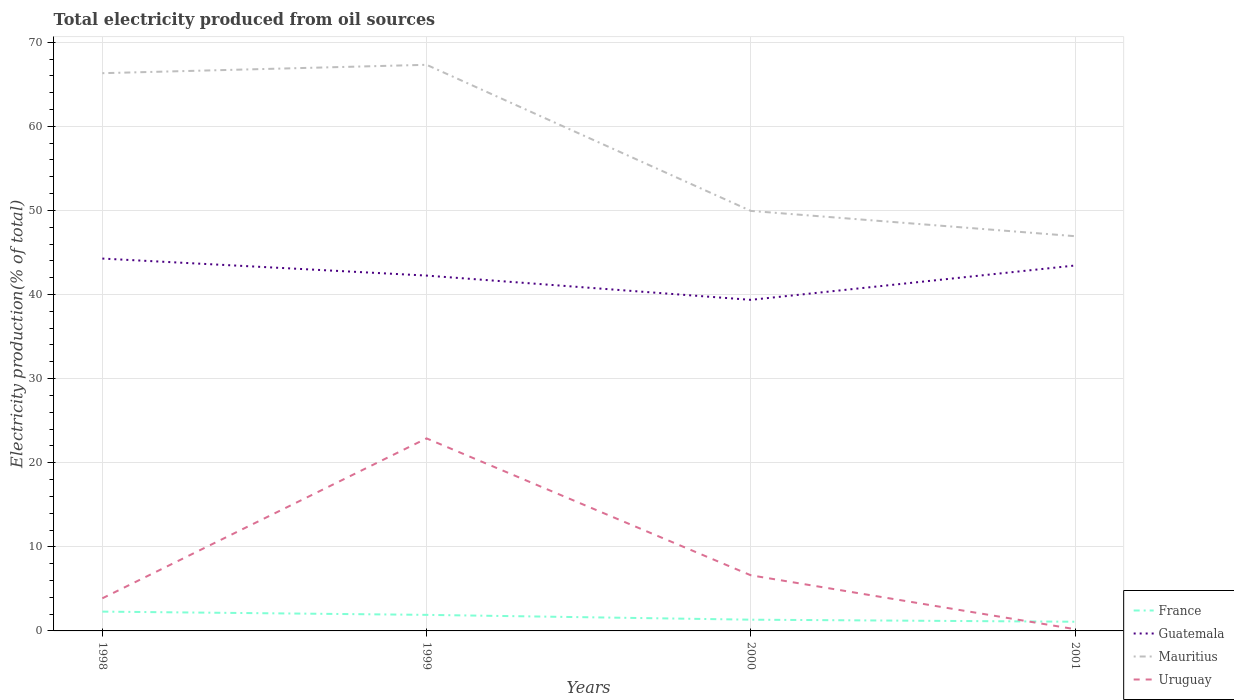Across all years, what is the maximum total electricity produced in Guatemala?
Your answer should be compact. 39.37. In which year was the total electricity produced in Uruguay maximum?
Provide a short and direct response. 2001. What is the total total electricity produced in Mauritius in the graph?
Give a very brief answer. 3. What is the difference between the highest and the second highest total electricity produced in Guatemala?
Your answer should be compact. 4.91. What is the difference between the highest and the lowest total electricity produced in Uruguay?
Provide a succinct answer. 1. Is the total electricity produced in Guatemala strictly greater than the total electricity produced in Mauritius over the years?
Your answer should be very brief. Yes. How many years are there in the graph?
Your answer should be very brief. 4. What is the difference between two consecutive major ticks on the Y-axis?
Ensure brevity in your answer.  10. How are the legend labels stacked?
Offer a very short reply. Vertical. What is the title of the graph?
Keep it short and to the point. Total electricity produced from oil sources. What is the Electricity production(% of total) of France in 1998?
Provide a succinct answer. 2.3. What is the Electricity production(% of total) in Guatemala in 1998?
Your answer should be very brief. 44.28. What is the Electricity production(% of total) in Mauritius in 1998?
Give a very brief answer. 66.32. What is the Electricity production(% of total) of Uruguay in 1998?
Give a very brief answer. 3.88. What is the Electricity production(% of total) of France in 1999?
Ensure brevity in your answer.  1.91. What is the Electricity production(% of total) in Guatemala in 1999?
Provide a short and direct response. 42.25. What is the Electricity production(% of total) in Mauritius in 1999?
Your response must be concise. 67.32. What is the Electricity production(% of total) of Uruguay in 1999?
Ensure brevity in your answer.  22.89. What is the Electricity production(% of total) in France in 2000?
Offer a very short reply. 1.34. What is the Electricity production(% of total) of Guatemala in 2000?
Your answer should be compact. 39.37. What is the Electricity production(% of total) of Mauritius in 2000?
Ensure brevity in your answer.  49.94. What is the Electricity production(% of total) of Uruguay in 2000?
Your response must be concise. 6.62. What is the Electricity production(% of total) of France in 2001?
Your response must be concise. 1.09. What is the Electricity production(% of total) in Guatemala in 2001?
Ensure brevity in your answer.  43.45. What is the Electricity production(% of total) of Mauritius in 2001?
Your answer should be compact. 46.94. What is the Electricity production(% of total) in Uruguay in 2001?
Offer a terse response. 0.21. Across all years, what is the maximum Electricity production(% of total) of France?
Your answer should be very brief. 2.3. Across all years, what is the maximum Electricity production(% of total) of Guatemala?
Provide a succinct answer. 44.28. Across all years, what is the maximum Electricity production(% of total) in Mauritius?
Keep it short and to the point. 67.32. Across all years, what is the maximum Electricity production(% of total) of Uruguay?
Provide a succinct answer. 22.89. Across all years, what is the minimum Electricity production(% of total) in France?
Give a very brief answer. 1.09. Across all years, what is the minimum Electricity production(% of total) in Guatemala?
Keep it short and to the point. 39.37. Across all years, what is the minimum Electricity production(% of total) of Mauritius?
Your answer should be very brief. 46.94. Across all years, what is the minimum Electricity production(% of total) in Uruguay?
Keep it short and to the point. 0.21. What is the total Electricity production(% of total) in France in the graph?
Provide a short and direct response. 6.63. What is the total Electricity production(% of total) in Guatemala in the graph?
Your answer should be compact. 169.35. What is the total Electricity production(% of total) in Mauritius in the graph?
Provide a short and direct response. 230.52. What is the total Electricity production(% of total) of Uruguay in the graph?
Make the answer very short. 33.59. What is the difference between the Electricity production(% of total) in France in 1998 and that in 1999?
Keep it short and to the point. 0.39. What is the difference between the Electricity production(% of total) of Guatemala in 1998 and that in 1999?
Your answer should be very brief. 2.02. What is the difference between the Electricity production(% of total) in Mauritius in 1998 and that in 1999?
Provide a succinct answer. -1. What is the difference between the Electricity production(% of total) of Uruguay in 1998 and that in 1999?
Your answer should be very brief. -19.02. What is the difference between the Electricity production(% of total) in France in 1998 and that in 2000?
Ensure brevity in your answer.  0.96. What is the difference between the Electricity production(% of total) in Guatemala in 1998 and that in 2000?
Give a very brief answer. 4.91. What is the difference between the Electricity production(% of total) of Mauritius in 1998 and that in 2000?
Keep it short and to the point. 16.38. What is the difference between the Electricity production(% of total) in Uruguay in 1998 and that in 2000?
Give a very brief answer. -2.74. What is the difference between the Electricity production(% of total) of France in 1998 and that in 2001?
Make the answer very short. 1.2. What is the difference between the Electricity production(% of total) in Guatemala in 1998 and that in 2001?
Offer a very short reply. 0.83. What is the difference between the Electricity production(% of total) of Mauritius in 1998 and that in 2001?
Make the answer very short. 19.38. What is the difference between the Electricity production(% of total) in Uruguay in 1998 and that in 2001?
Offer a very short reply. 3.67. What is the difference between the Electricity production(% of total) in France in 1999 and that in 2000?
Your answer should be compact. 0.57. What is the difference between the Electricity production(% of total) of Guatemala in 1999 and that in 2000?
Your answer should be very brief. 2.89. What is the difference between the Electricity production(% of total) of Mauritius in 1999 and that in 2000?
Offer a terse response. 17.37. What is the difference between the Electricity production(% of total) of Uruguay in 1999 and that in 2000?
Ensure brevity in your answer.  16.28. What is the difference between the Electricity production(% of total) of France in 1999 and that in 2001?
Your answer should be very brief. 0.82. What is the difference between the Electricity production(% of total) in Guatemala in 1999 and that in 2001?
Ensure brevity in your answer.  -1.2. What is the difference between the Electricity production(% of total) of Mauritius in 1999 and that in 2001?
Keep it short and to the point. 20.38. What is the difference between the Electricity production(% of total) of Uruguay in 1999 and that in 2001?
Your answer should be very brief. 22.69. What is the difference between the Electricity production(% of total) of France in 2000 and that in 2001?
Keep it short and to the point. 0.24. What is the difference between the Electricity production(% of total) in Guatemala in 2000 and that in 2001?
Your answer should be compact. -4.08. What is the difference between the Electricity production(% of total) in Mauritius in 2000 and that in 2001?
Provide a succinct answer. 3. What is the difference between the Electricity production(% of total) in Uruguay in 2000 and that in 2001?
Provide a short and direct response. 6.41. What is the difference between the Electricity production(% of total) in France in 1998 and the Electricity production(% of total) in Guatemala in 1999?
Make the answer very short. -39.96. What is the difference between the Electricity production(% of total) in France in 1998 and the Electricity production(% of total) in Mauritius in 1999?
Your answer should be compact. -65.02. What is the difference between the Electricity production(% of total) of France in 1998 and the Electricity production(% of total) of Uruguay in 1999?
Your answer should be compact. -20.6. What is the difference between the Electricity production(% of total) of Guatemala in 1998 and the Electricity production(% of total) of Mauritius in 1999?
Provide a short and direct response. -23.04. What is the difference between the Electricity production(% of total) of Guatemala in 1998 and the Electricity production(% of total) of Uruguay in 1999?
Your answer should be compact. 21.38. What is the difference between the Electricity production(% of total) of Mauritius in 1998 and the Electricity production(% of total) of Uruguay in 1999?
Offer a very short reply. 43.43. What is the difference between the Electricity production(% of total) in France in 1998 and the Electricity production(% of total) in Guatemala in 2000?
Make the answer very short. -37.07. What is the difference between the Electricity production(% of total) of France in 1998 and the Electricity production(% of total) of Mauritius in 2000?
Ensure brevity in your answer.  -47.65. What is the difference between the Electricity production(% of total) in France in 1998 and the Electricity production(% of total) in Uruguay in 2000?
Provide a succinct answer. -4.32. What is the difference between the Electricity production(% of total) in Guatemala in 1998 and the Electricity production(% of total) in Mauritius in 2000?
Offer a terse response. -5.67. What is the difference between the Electricity production(% of total) of Guatemala in 1998 and the Electricity production(% of total) of Uruguay in 2000?
Your answer should be compact. 37.66. What is the difference between the Electricity production(% of total) in Mauritius in 1998 and the Electricity production(% of total) in Uruguay in 2000?
Ensure brevity in your answer.  59.7. What is the difference between the Electricity production(% of total) of France in 1998 and the Electricity production(% of total) of Guatemala in 2001?
Keep it short and to the point. -41.16. What is the difference between the Electricity production(% of total) in France in 1998 and the Electricity production(% of total) in Mauritius in 2001?
Offer a very short reply. -44.64. What is the difference between the Electricity production(% of total) of France in 1998 and the Electricity production(% of total) of Uruguay in 2001?
Your answer should be very brief. 2.09. What is the difference between the Electricity production(% of total) in Guatemala in 1998 and the Electricity production(% of total) in Mauritius in 2001?
Your answer should be compact. -2.66. What is the difference between the Electricity production(% of total) of Guatemala in 1998 and the Electricity production(% of total) of Uruguay in 2001?
Make the answer very short. 44.07. What is the difference between the Electricity production(% of total) in Mauritius in 1998 and the Electricity production(% of total) in Uruguay in 2001?
Offer a very short reply. 66.11. What is the difference between the Electricity production(% of total) of France in 1999 and the Electricity production(% of total) of Guatemala in 2000?
Your answer should be compact. -37.46. What is the difference between the Electricity production(% of total) of France in 1999 and the Electricity production(% of total) of Mauritius in 2000?
Keep it short and to the point. -48.03. What is the difference between the Electricity production(% of total) of France in 1999 and the Electricity production(% of total) of Uruguay in 2000?
Ensure brevity in your answer.  -4.71. What is the difference between the Electricity production(% of total) in Guatemala in 1999 and the Electricity production(% of total) in Mauritius in 2000?
Keep it short and to the point. -7.69. What is the difference between the Electricity production(% of total) of Guatemala in 1999 and the Electricity production(% of total) of Uruguay in 2000?
Your answer should be compact. 35.64. What is the difference between the Electricity production(% of total) in Mauritius in 1999 and the Electricity production(% of total) in Uruguay in 2000?
Provide a succinct answer. 60.7. What is the difference between the Electricity production(% of total) in France in 1999 and the Electricity production(% of total) in Guatemala in 2001?
Offer a very short reply. -41.54. What is the difference between the Electricity production(% of total) of France in 1999 and the Electricity production(% of total) of Mauritius in 2001?
Provide a succinct answer. -45.03. What is the difference between the Electricity production(% of total) in France in 1999 and the Electricity production(% of total) in Uruguay in 2001?
Offer a terse response. 1.7. What is the difference between the Electricity production(% of total) in Guatemala in 1999 and the Electricity production(% of total) in Mauritius in 2001?
Your answer should be very brief. -4.69. What is the difference between the Electricity production(% of total) of Guatemala in 1999 and the Electricity production(% of total) of Uruguay in 2001?
Ensure brevity in your answer.  42.05. What is the difference between the Electricity production(% of total) in Mauritius in 1999 and the Electricity production(% of total) in Uruguay in 2001?
Keep it short and to the point. 67.11. What is the difference between the Electricity production(% of total) in France in 2000 and the Electricity production(% of total) in Guatemala in 2001?
Provide a succinct answer. -42.12. What is the difference between the Electricity production(% of total) in France in 2000 and the Electricity production(% of total) in Mauritius in 2001?
Give a very brief answer. -45.6. What is the difference between the Electricity production(% of total) of France in 2000 and the Electricity production(% of total) of Uruguay in 2001?
Make the answer very short. 1.13. What is the difference between the Electricity production(% of total) in Guatemala in 2000 and the Electricity production(% of total) in Mauritius in 2001?
Offer a terse response. -7.57. What is the difference between the Electricity production(% of total) in Guatemala in 2000 and the Electricity production(% of total) in Uruguay in 2001?
Give a very brief answer. 39.16. What is the difference between the Electricity production(% of total) in Mauritius in 2000 and the Electricity production(% of total) in Uruguay in 2001?
Ensure brevity in your answer.  49.74. What is the average Electricity production(% of total) of France per year?
Make the answer very short. 1.66. What is the average Electricity production(% of total) in Guatemala per year?
Keep it short and to the point. 42.34. What is the average Electricity production(% of total) of Mauritius per year?
Provide a succinct answer. 57.63. What is the average Electricity production(% of total) of Uruguay per year?
Provide a succinct answer. 8.4. In the year 1998, what is the difference between the Electricity production(% of total) in France and Electricity production(% of total) in Guatemala?
Give a very brief answer. -41.98. In the year 1998, what is the difference between the Electricity production(% of total) of France and Electricity production(% of total) of Mauritius?
Provide a short and direct response. -64.02. In the year 1998, what is the difference between the Electricity production(% of total) in France and Electricity production(% of total) in Uruguay?
Your answer should be very brief. -1.58. In the year 1998, what is the difference between the Electricity production(% of total) in Guatemala and Electricity production(% of total) in Mauritius?
Ensure brevity in your answer.  -22.04. In the year 1998, what is the difference between the Electricity production(% of total) of Guatemala and Electricity production(% of total) of Uruguay?
Provide a succinct answer. 40.4. In the year 1998, what is the difference between the Electricity production(% of total) of Mauritius and Electricity production(% of total) of Uruguay?
Offer a very short reply. 62.44. In the year 1999, what is the difference between the Electricity production(% of total) of France and Electricity production(% of total) of Guatemala?
Keep it short and to the point. -40.34. In the year 1999, what is the difference between the Electricity production(% of total) of France and Electricity production(% of total) of Mauritius?
Ensure brevity in your answer.  -65.41. In the year 1999, what is the difference between the Electricity production(% of total) in France and Electricity production(% of total) in Uruguay?
Keep it short and to the point. -20.98. In the year 1999, what is the difference between the Electricity production(% of total) of Guatemala and Electricity production(% of total) of Mauritius?
Your answer should be compact. -25.07. In the year 1999, what is the difference between the Electricity production(% of total) in Guatemala and Electricity production(% of total) in Uruguay?
Offer a terse response. 19.36. In the year 1999, what is the difference between the Electricity production(% of total) of Mauritius and Electricity production(% of total) of Uruguay?
Keep it short and to the point. 44.42. In the year 2000, what is the difference between the Electricity production(% of total) in France and Electricity production(% of total) in Guatemala?
Your response must be concise. -38.03. In the year 2000, what is the difference between the Electricity production(% of total) of France and Electricity production(% of total) of Mauritius?
Your answer should be very brief. -48.61. In the year 2000, what is the difference between the Electricity production(% of total) of France and Electricity production(% of total) of Uruguay?
Give a very brief answer. -5.28. In the year 2000, what is the difference between the Electricity production(% of total) in Guatemala and Electricity production(% of total) in Mauritius?
Make the answer very short. -10.58. In the year 2000, what is the difference between the Electricity production(% of total) of Guatemala and Electricity production(% of total) of Uruguay?
Give a very brief answer. 32.75. In the year 2000, what is the difference between the Electricity production(% of total) in Mauritius and Electricity production(% of total) in Uruguay?
Offer a very short reply. 43.33. In the year 2001, what is the difference between the Electricity production(% of total) in France and Electricity production(% of total) in Guatemala?
Provide a succinct answer. -42.36. In the year 2001, what is the difference between the Electricity production(% of total) of France and Electricity production(% of total) of Mauritius?
Provide a succinct answer. -45.85. In the year 2001, what is the difference between the Electricity production(% of total) of France and Electricity production(% of total) of Uruguay?
Offer a very short reply. 0.89. In the year 2001, what is the difference between the Electricity production(% of total) of Guatemala and Electricity production(% of total) of Mauritius?
Your response must be concise. -3.49. In the year 2001, what is the difference between the Electricity production(% of total) of Guatemala and Electricity production(% of total) of Uruguay?
Give a very brief answer. 43.25. In the year 2001, what is the difference between the Electricity production(% of total) in Mauritius and Electricity production(% of total) in Uruguay?
Give a very brief answer. 46.73. What is the ratio of the Electricity production(% of total) of France in 1998 to that in 1999?
Give a very brief answer. 1.2. What is the ratio of the Electricity production(% of total) of Guatemala in 1998 to that in 1999?
Your answer should be compact. 1.05. What is the ratio of the Electricity production(% of total) in Mauritius in 1998 to that in 1999?
Your response must be concise. 0.99. What is the ratio of the Electricity production(% of total) of Uruguay in 1998 to that in 1999?
Your answer should be compact. 0.17. What is the ratio of the Electricity production(% of total) of France in 1998 to that in 2000?
Make the answer very short. 1.72. What is the ratio of the Electricity production(% of total) of Guatemala in 1998 to that in 2000?
Ensure brevity in your answer.  1.12. What is the ratio of the Electricity production(% of total) of Mauritius in 1998 to that in 2000?
Your response must be concise. 1.33. What is the ratio of the Electricity production(% of total) of Uruguay in 1998 to that in 2000?
Make the answer very short. 0.59. What is the ratio of the Electricity production(% of total) in France in 1998 to that in 2001?
Ensure brevity in your answer.  2.1. What is the ratio of the Electricity production(% of total) of Guatemala in 1998 to that in 2001?
Ensure brevity in your answer.  1.02. What is the ratio of the Electricity production(% of total) in Mauritius in 1998 to that in 2001?
Provide a succinct answer. 1.41. What is the ratio of the Electricity production(% of total) in Uruguay in 1998 to that in 2001?
Ensure brevity in your answer.  18.88. What is the ratio of the Electricity production(% of total) in France in 1999 to that in 2000?
Your response must be concise. 1.43. What is the ratio of the Electricity production(% of total) in Guatemala in 1999 to that in 2000?
Provide a succinct answer. 1.07. What is the ratio of the Electricity production(% of total) in Mauritius in 1999 to that in 2000?
Your answer should be very brief. 1.35. What is the ratio of the Electricity production(% of total) in Uruguay in 1999 to that in 2000?
Offer a terse response. 3.46. What is the ratio of the Electricity production(% of total) in France in 1999 to that in 2001?
Offer a terse response. 1.75. What is the ratio of the Electricity production(% of total) of Guatemala in 1999 to that in 2001?
Keep it short and to the point. 0.97. What is the ratio of the Electricity production(% of total) of Mauritius in 1999 to that in 2001?
Provide a short and direct response. 1.43. What is the ratio of the Electricity production(% of total) in Uruguay in 1999 to that in 2001?
Offer a very short reply. 111.46. What is the ratio of the Electricity production(% of total) in France in 2000 to that in 2001?
Your answer should be very brief. 1.22. What is the ratio of the Electricity production(% of total) of Guatemala in 2000 to that in 2001?
Provide a short and direct response. 0.91. What is the ratio of the Electricity production(% of total) of Mauritius in 2000 to that in 2001?
Offer a terse response. 1.06. What is the ratio of the Electricity production(% of total) of Uruguay in 2000 to that in 2001?
Your response must be concise. 32.21. What is the difference between the highest and the second highest Electricity production(% of total) in France?
Give a very brief answer. 0.39. What is the difference between the highest and the second highest Electricity production(% of total) of Guatemala?
Provide a succinct answer. 0.83. What is the difference between the highest and the second highest Electricity production(% of total) of Uruguay?
Make the answer very short. 16.28. What is the difference between the highest and the lowest Electricity production(% of total) of France?
Your response must be concise. 1.2. What is the difference between the highest and the lowest Electricity production(% of total) in Guatemala?
Your answer should be compact. 4.91. What is the difference between the highest and the lowest Electricity production(% of total) in Mauritius?
Offer a very short reply. 20.38. What is the difference between the highest and the lowest Electricity production(% of total) in Uruguay?
Make the answer very short. 22.69. 